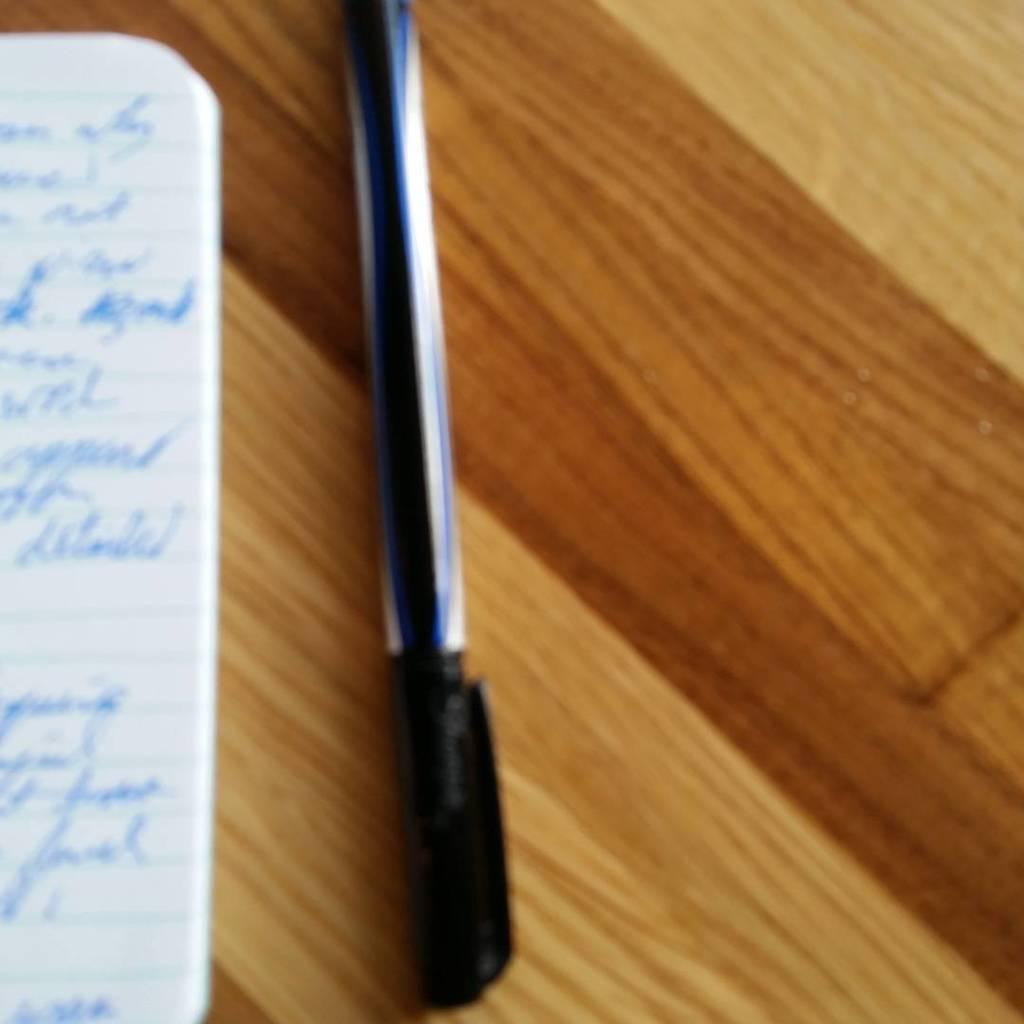What is on the brown color table in the image? There is a paper and a pen on the brown color table in the image. What color is the paper in the image? The paper is white in color. What color is the pen in the image? The pen is black in color. What arithmetic problem is being solved on the paper in the image? There is no arithmetic problem visible on the paper in the image. In which direction is the pen pointing on the brown color table? The pen is not pointing in any specific direction on the brown color table in the image. 